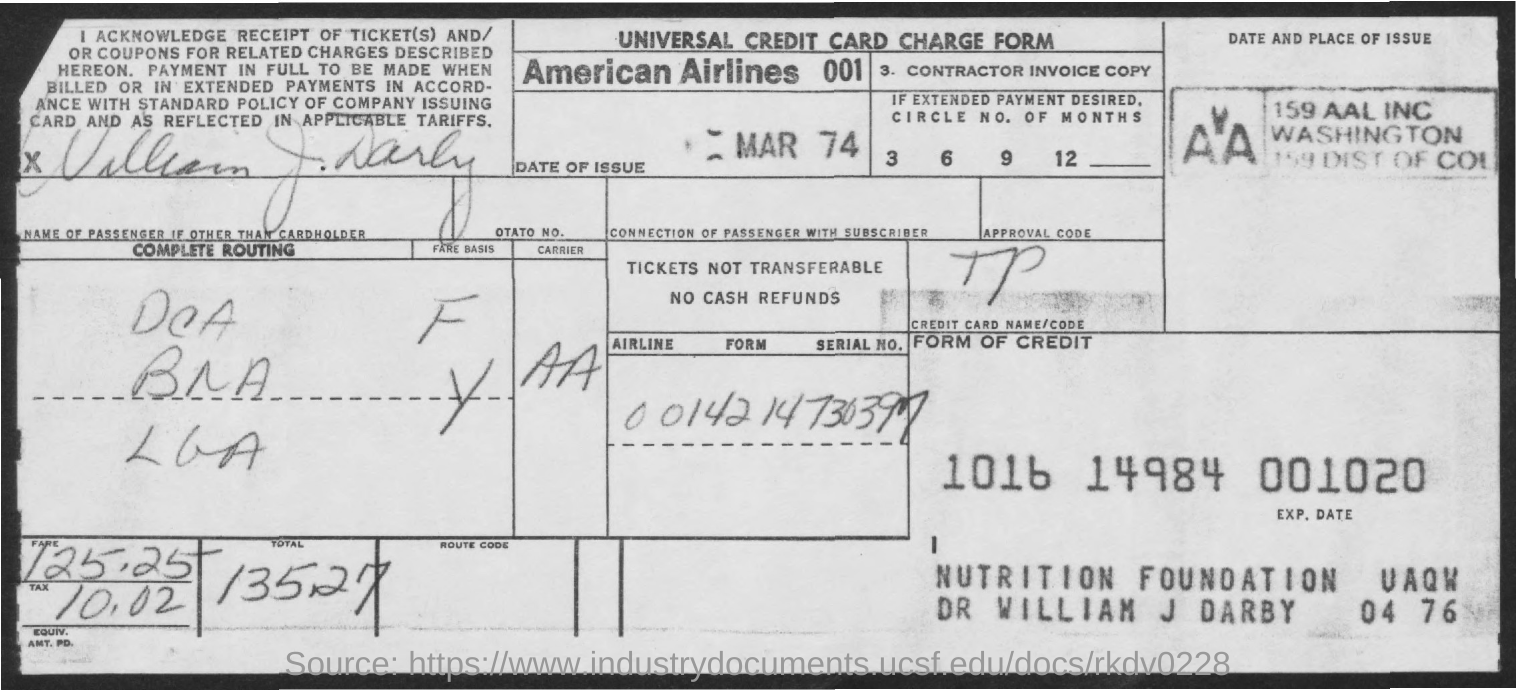What is the month and year of issue
Offer a very short reply. MAR 74. How much is the total amount ?
Give a very brief answer. 135 27. How much is the fare amount ?
Your answer should be very brief. 125 25. How much is the tax amount
Provide a succinct answer. 10.02. 